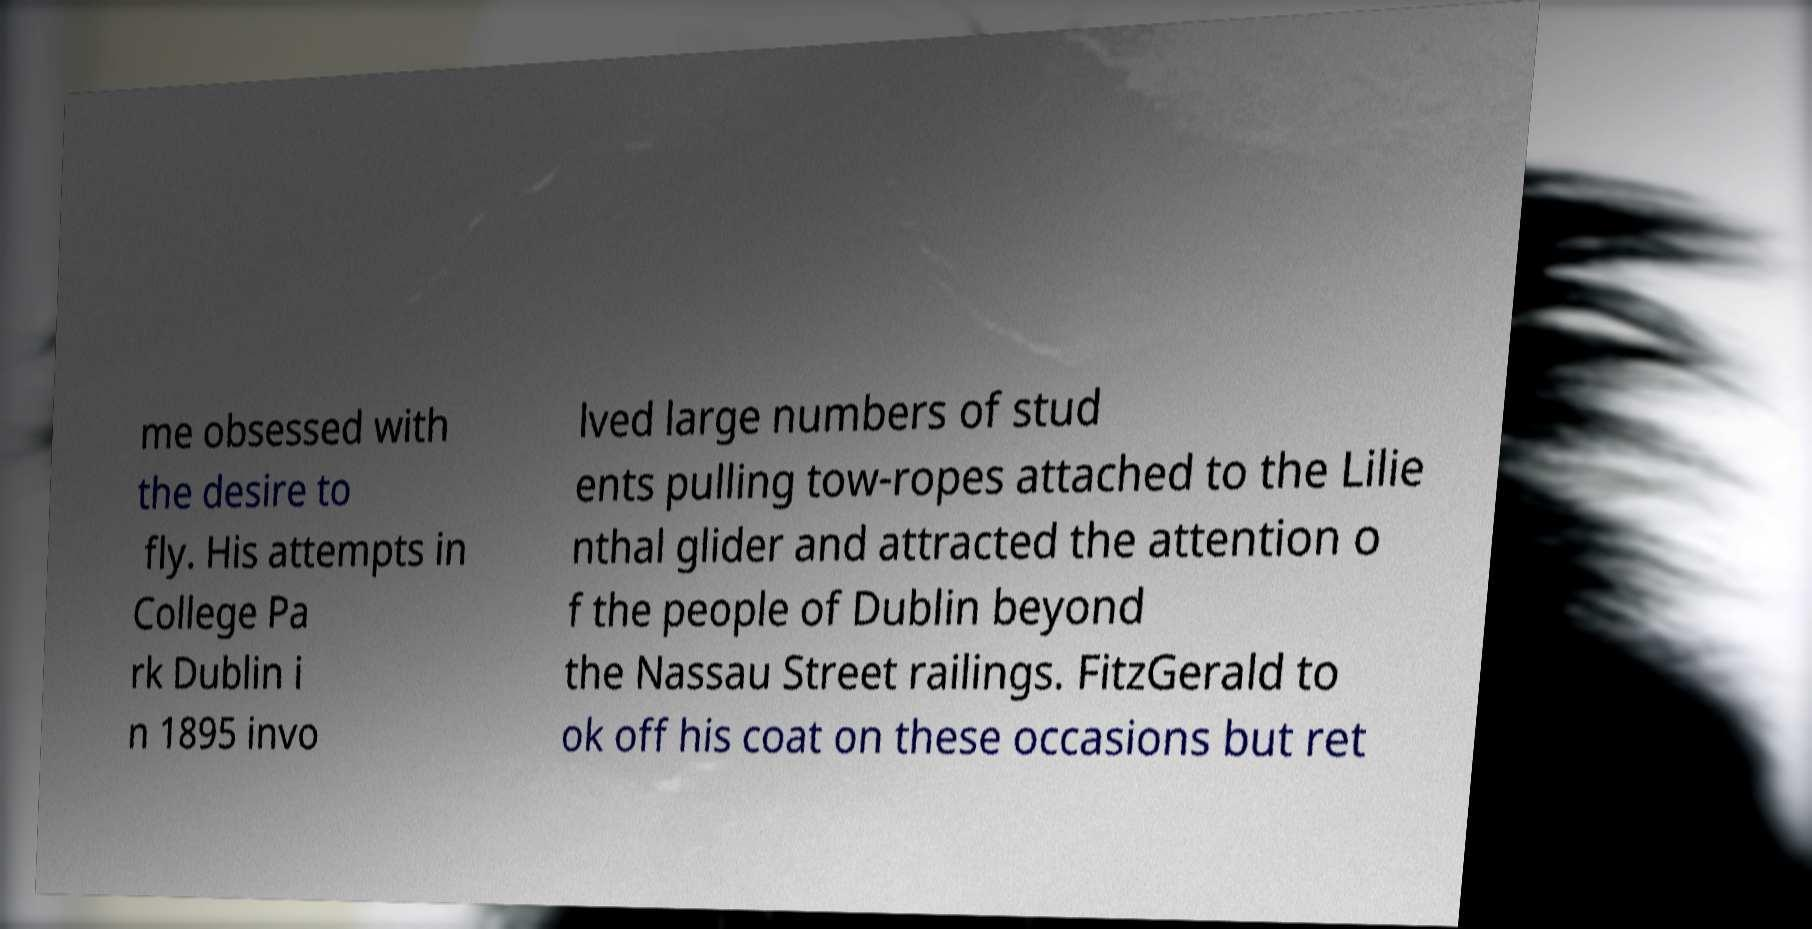Could you assist in decoding the text presented in this image and type it out clearly? me obsessed with the desire to fly. His attempts in College Pa rk Dublin i n 1895 invo lved large numbers of stud ents pulling tow-ropes attached to the Lilie nthal glider and attracted the attention o f the people of Dublin beyond the Nassau Street railings. FitzGerald to ok off his coat on these occasions but ret 